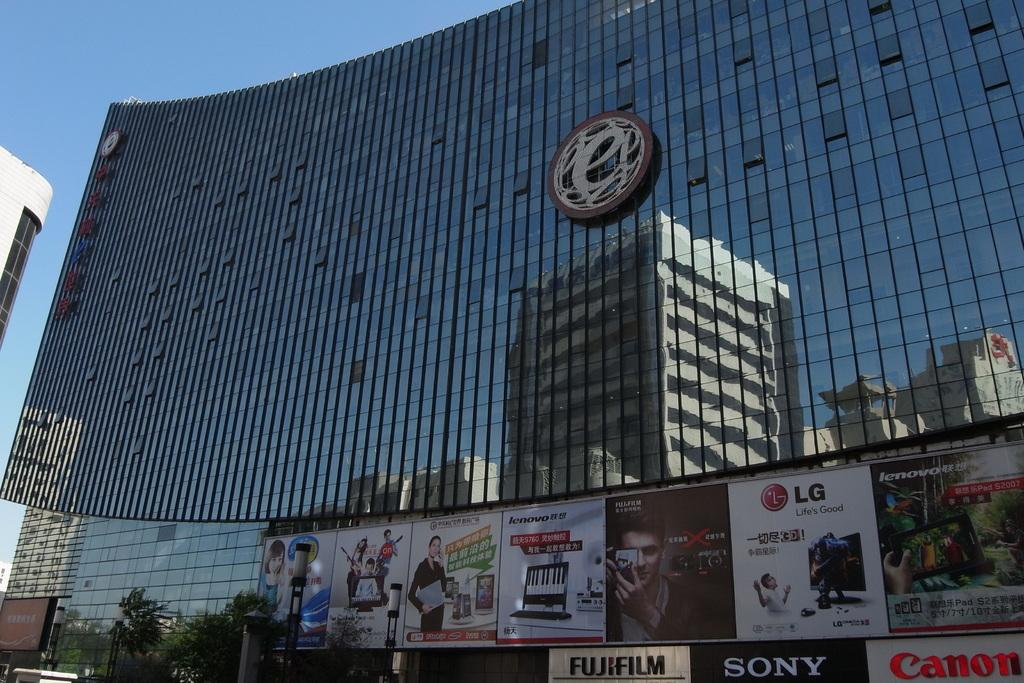What type of structure is present in the image? There is a building in the picture. What feature can be observed on the building? The building has glass walls or windows. Are there any additional elements near the building? Yes, there are banners on or near the building. How many frogs are sitting on the banners in the image? There are no frogs present in the image, and therefore no such activity can be observed. 